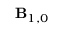Convert formula to latex. <formula><loc_0><loc_0><loc_500><loc_500>B _ { 1 , 0 }</formula> 